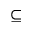<formula> <loc_0><loc_0><loc_500><loc_500>\subseteq</formula> 